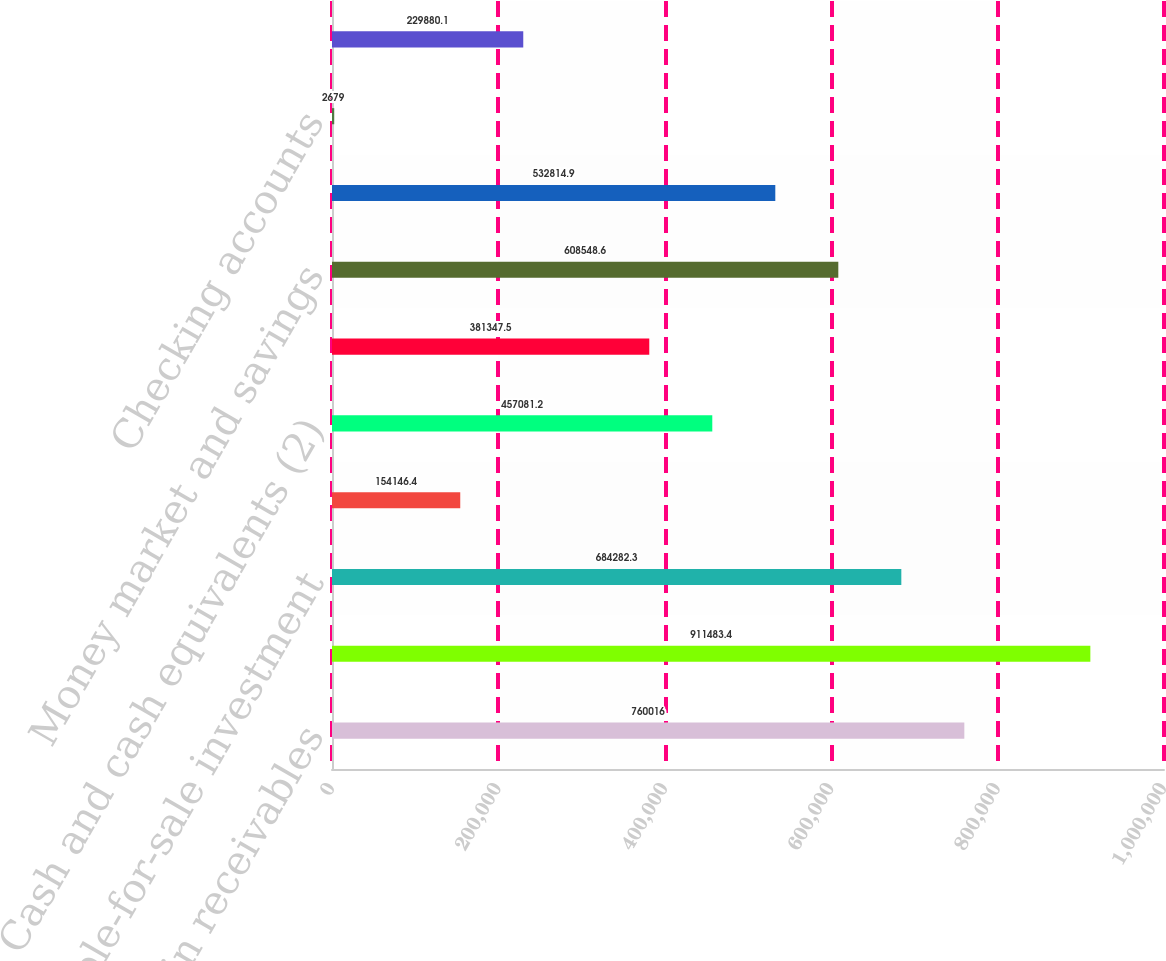Convert chart. <chart><loc_0><loc_0><loc_500><loc_500><bar_chart><fcel>Margin receivables<fcel>Mortgage-backed and related<fcel>Available-for-sale investment<fcel>Trading securities<fcel>Cash and cash equivalents (2)<fcel>Stock borrow and other<fcel>Money market and savings<fcel>Certificates of deposit<fcel>Checking accounts<fcel>Brokered certificates of<nl><fcel>760016<fcel>911483<fcel>684282<fcel>154146<fcel>457081<fcel>381348<fcel>608549<fcel>532815<fcel>2679<fcel>229880<nl></chart> 